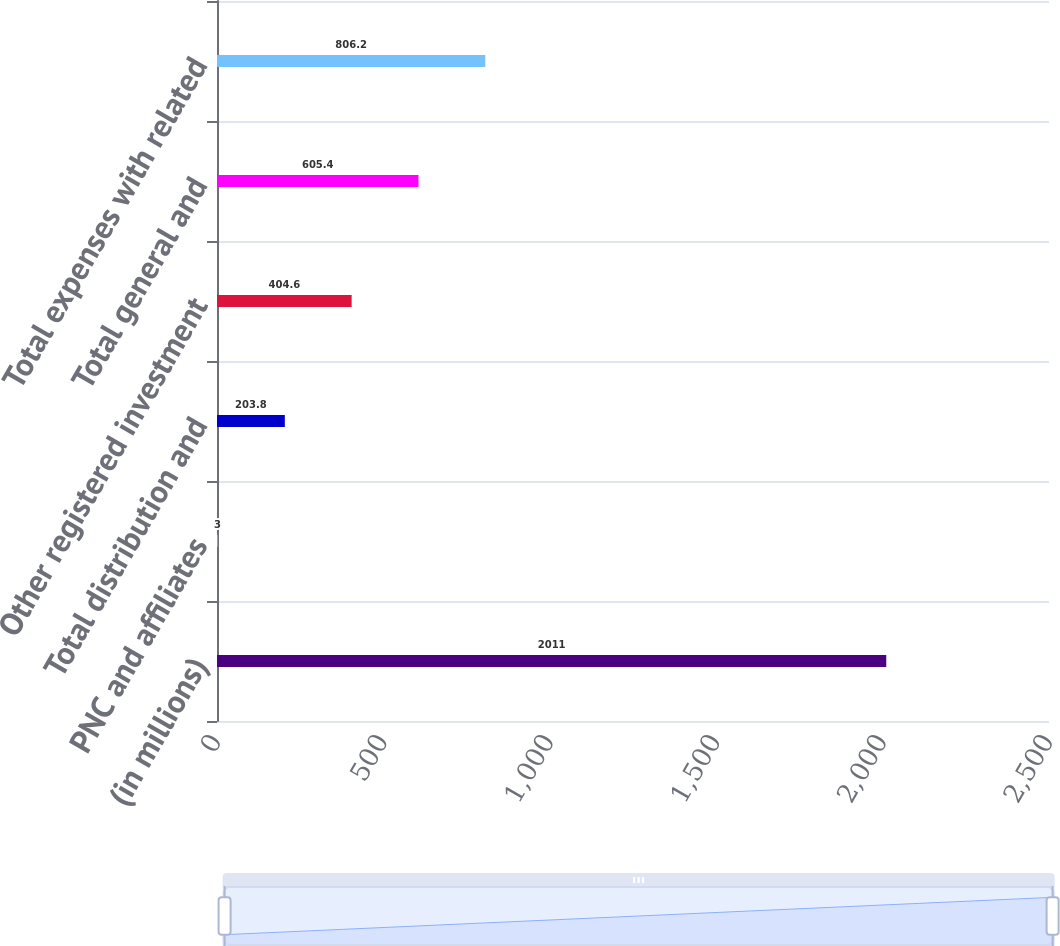<chart> <loc_0><loc_0><loc_500><loc_500><bar_chart><fcel>(in millions)<fcel>PNC and affiliates<fcel>Total distribution and<fcel>Other registered investment<fcel>Total general and<fcel>Total expenses with related<nl><fcel>2011<fcel>3<fcel>203.8<fcel>404.6<fcel>605.4<fcel>806.2<nl></chart> 